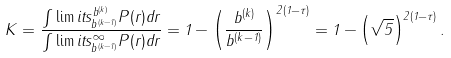<formula> <loc_0><loc_0><loc_500><loc_500>K = \frac { \int \lim i t s _ { b ^ { ( k - 1 ) } } ^ { b ^ { ( k ) } } P ( r ) d r } { \int \lim i t s _ { b ^ { ( k - 1 ) } } ^ { \infty } P ( r ) d r } = 1 - \left ( \frac { b ^ { ( k ) } } { b ^ { ( k - 1 ) } } \right ) ^ { 2 ( 1 - \tau ) } = 1 - \left ( \sqrt { 5 } \right ) ^ { 2 ( 1 - \tau ) } .</formula> 